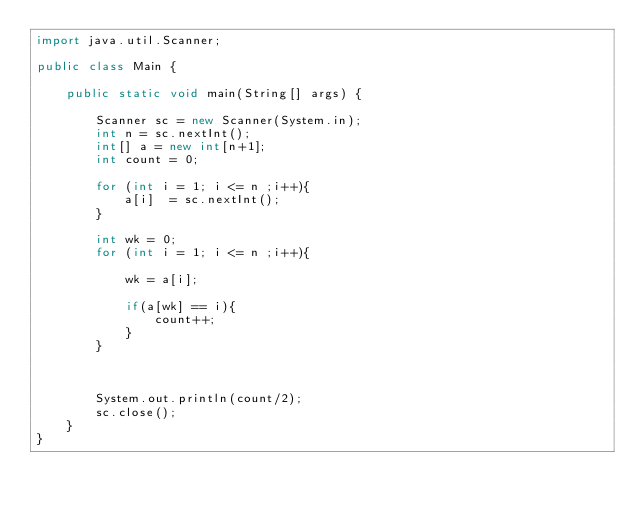Convert code to text. <code><loc_0><loc_0><loc_500><loc_500><_Java_>import java.util.Scanner;

public class Main {

	public static void main(String[] args) {

		Scanner sc = new Scanner(System.in);
		int n = sc.nextInt();
		int[] a = new int[n+1];
		int count = 0;

		for (int i = 1; i <= n ;i++){
			a[i]  = sc.nextInt();
		}

		int wk = 0;
		for (int i = 1; i <= n ;i++){

			wk = a[i];

			if(a[wk] == i){
				count++;
			}
		}



		System.out.println(count/2);
		sc.close();
	}
}
</code> 